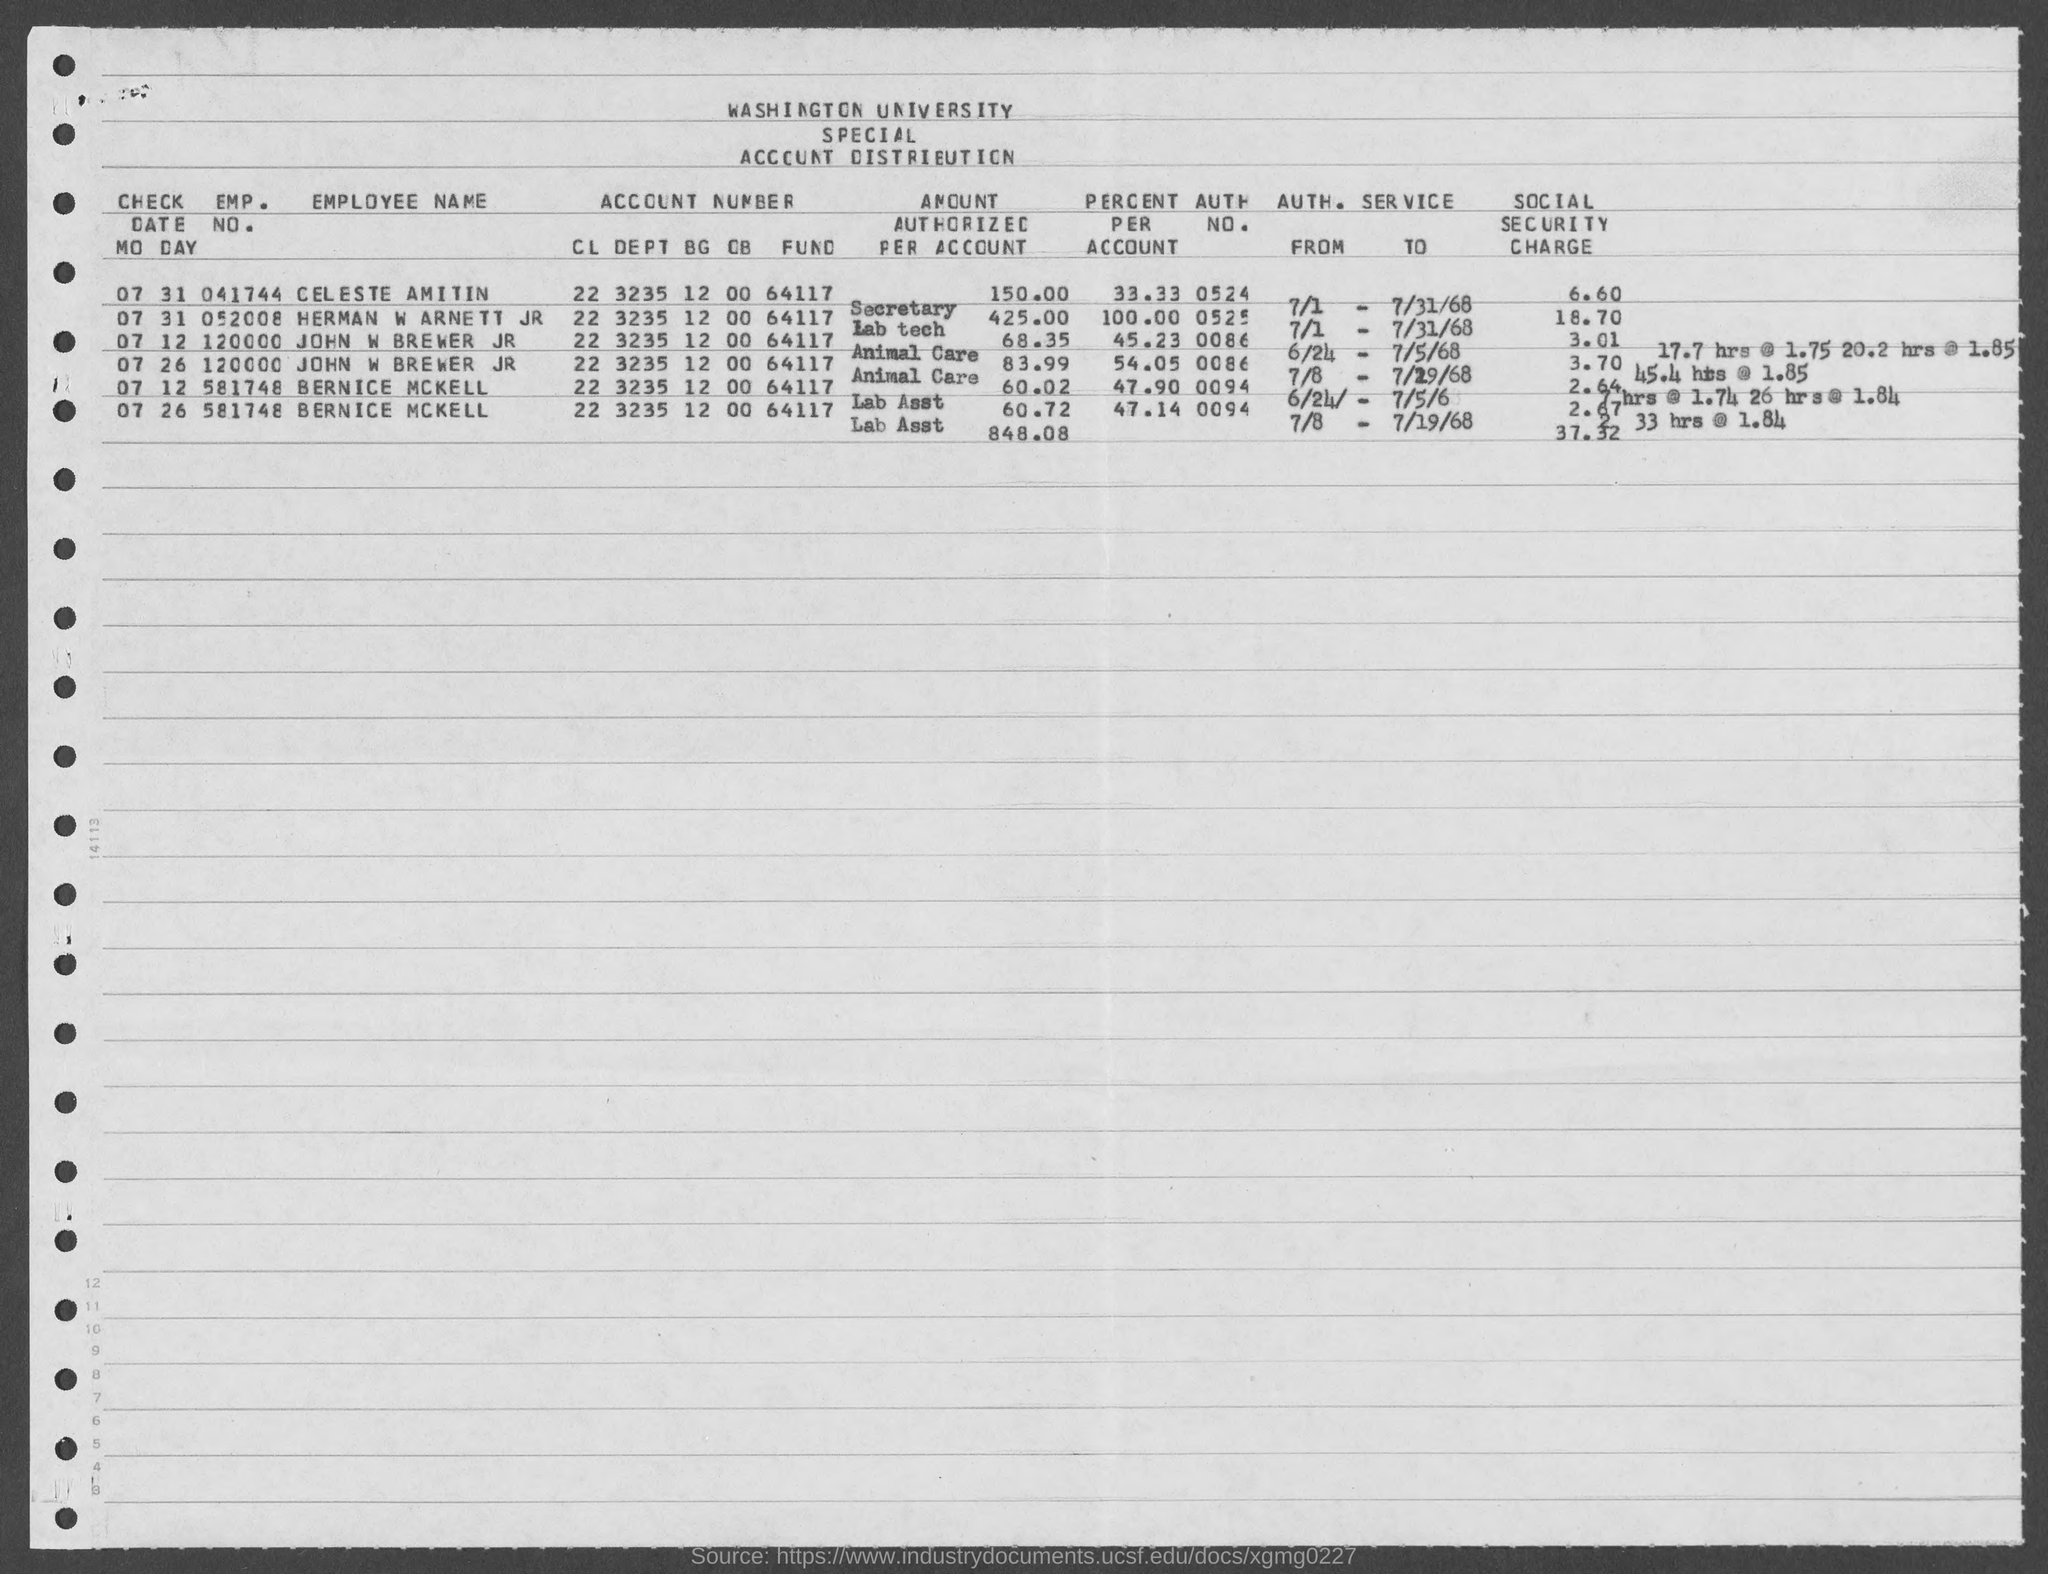What is the emp. no. of john w brewer jr as mentioned in the given page ?
Provide a succinct answer. 120000. What is the emp. no. of celeste amitin ?
Your response must be concise. 041744. What is the emp. no. of herman w arnett jr ?
Provide a succinct answer. 052008. What is the emp. no. of bernice mckell as mentioned in the given form ?
Offer a very short reply. 581748. 